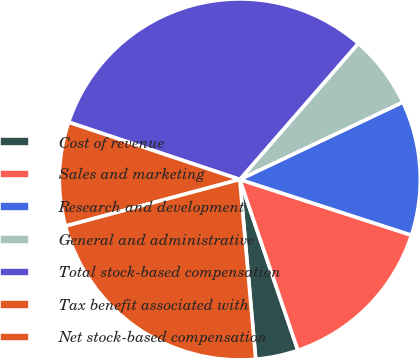<chart> <loc_0><loc_0><loc_500><loc_500><pie_chart><fcel>Cost of revenue<fcel>Sales and marketing<fcel>Research and development<fcel>General and administrative<fcel>Total stock-based compensation<fcel>Tax benefit associated with<fcel>Net stock-based compensation<nl><fcel>3.81%<fcel>14.79%<fcel>12.04%<fcel>6.55%<fcel>31.26%<fcel>9.3%<fcel>22.24%<nl></chart> 